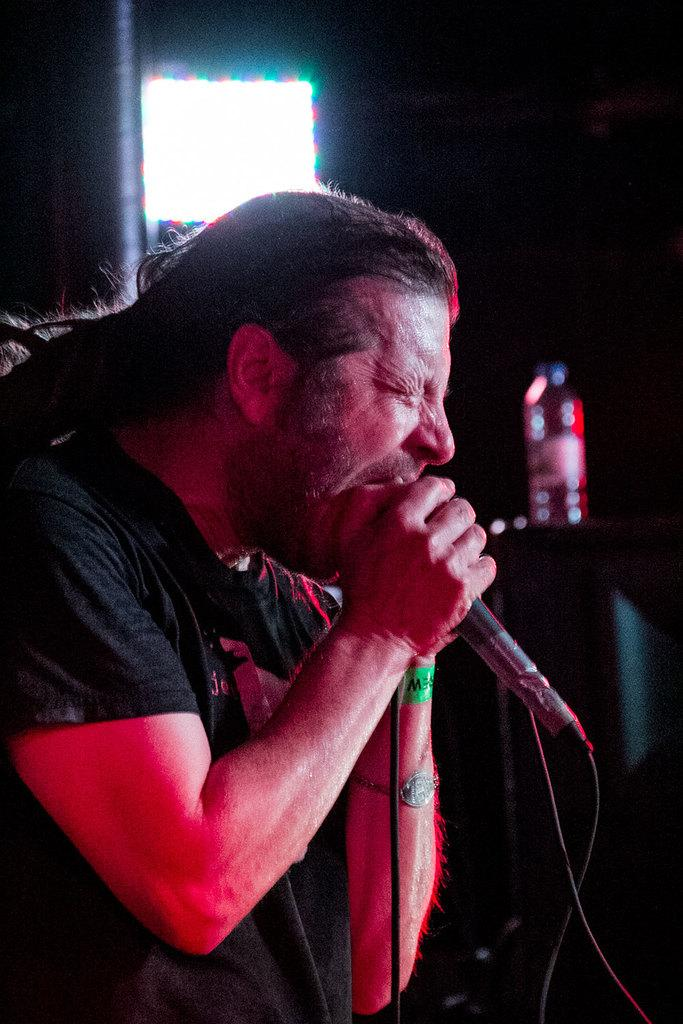What is the person in the image doing? The person is holding a mic. What object is the person holding? The person is holding a mic. Can you describe anything else in the background of the image? There is a bottle on a table in the background of the image. What is the profit margin of the argument between the cent and the bottle in the image? There is no mention of profit, argument, or cent in the image, so this question cannot be answered. 